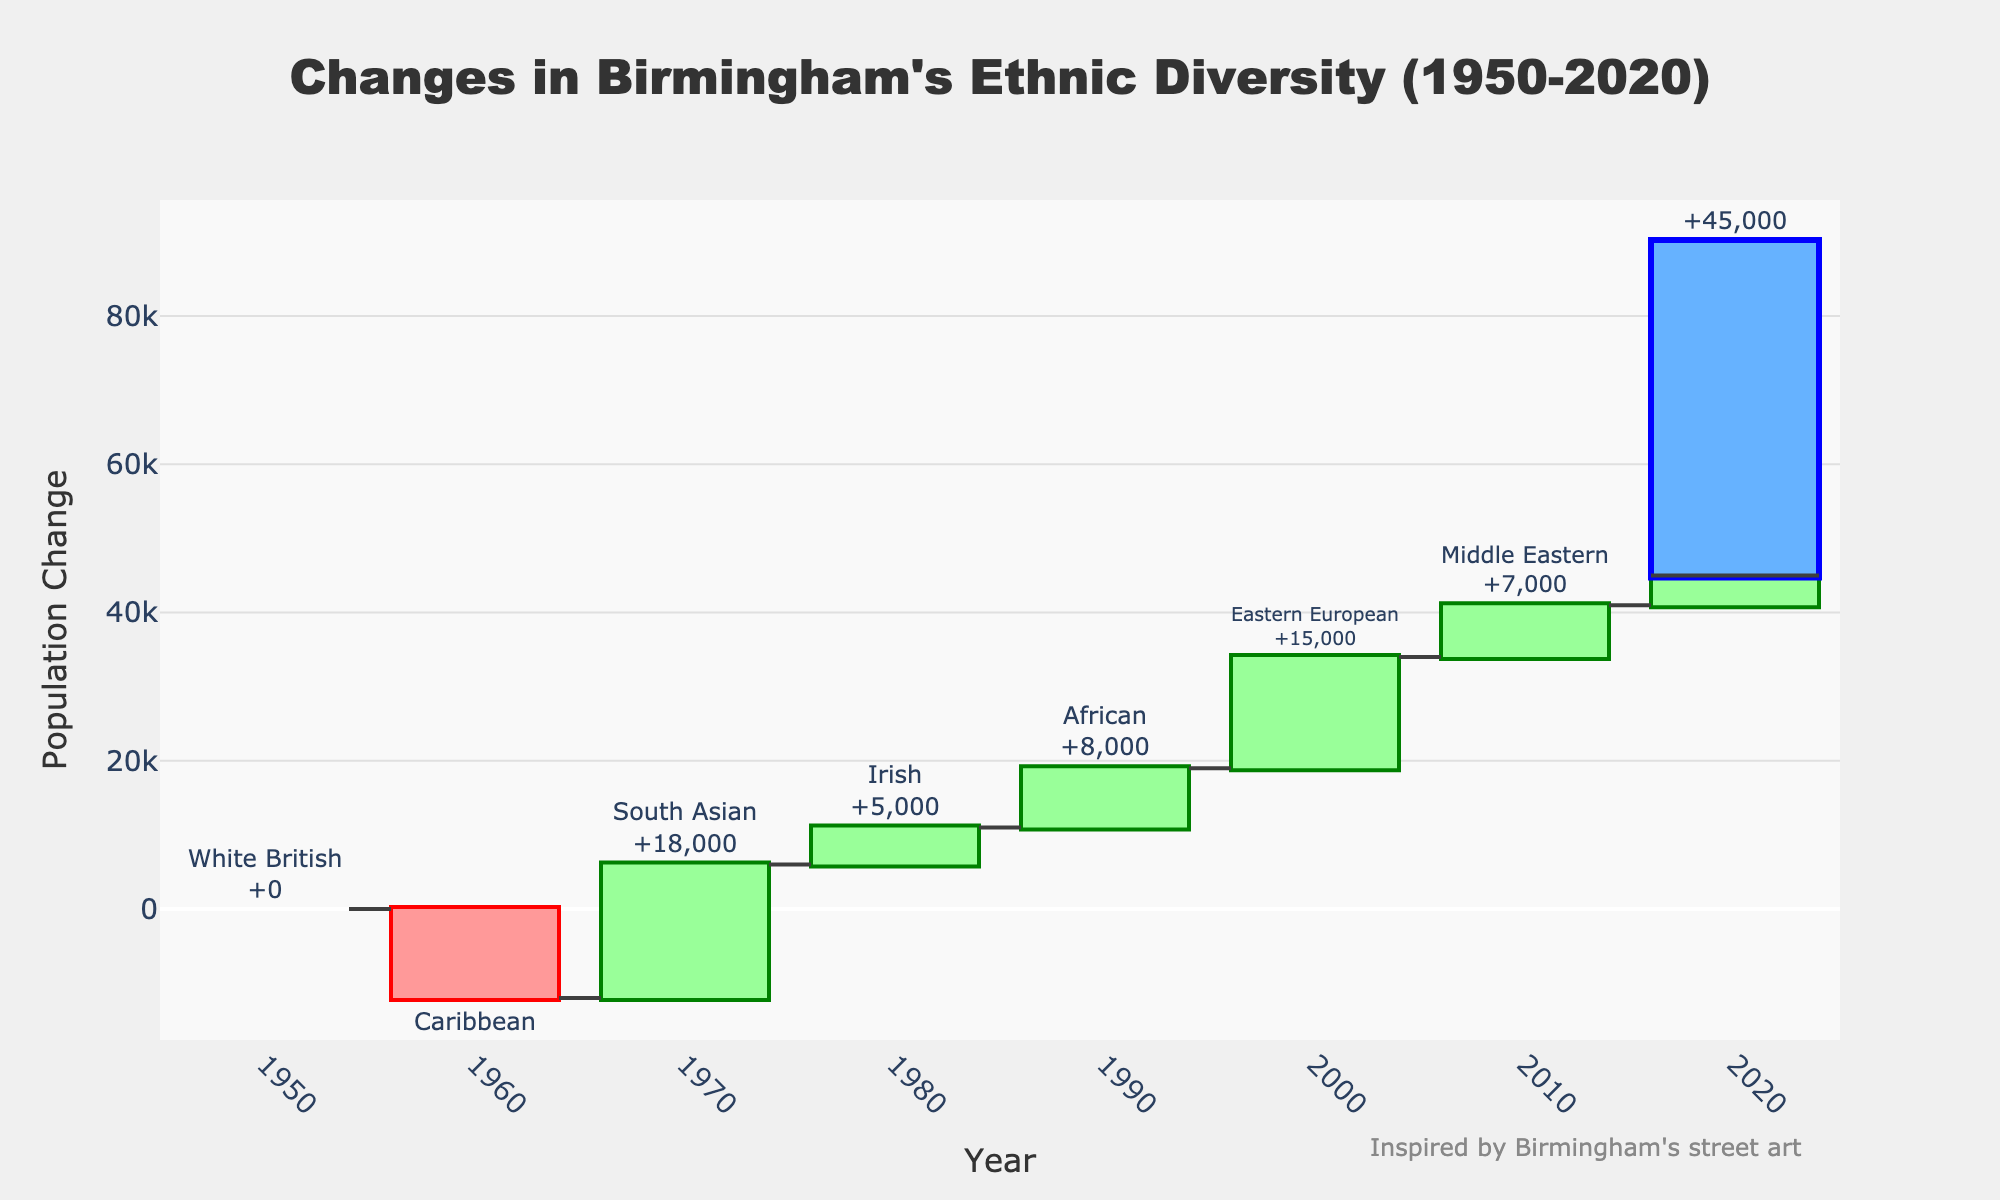What is the title of the chart? The title of the chart is at the top and reads "Changes in Birmingham's Ethnic Diversity (1950-2020).
Answer: Changes in Birmingham's Ethnic Diversity (1950-2020) How many ethnic groups are tracked in the chart? Each bar excluding the total bar represents a different ethnic group. Counting these bars gives us seven different ethnic groups.
Answer: Seven Which ethnic group saw the largest increase in population change? By visually inspecting the bars, the South Asian ethnic group (1970) has the largest increase, indicated by the tallest green bar.
Answer: South Asian What is the total change in ethnic diversity by 2020? The total change is represented by the final bar, which sums all previous changes and is labeled as 45,000.
Answer: 45,000 Which ethnic group experienced a decrease in population change and by how much? The only ethnic group with a red (decreasing) bar is the Caribbean (1960) with a change of -12,000.
Answer: Caribbean, -12,000 What was the combined population change for African and Eastern European ethnic groups? The change for African is 8,000 and for Eastern European is 15,000. Combined, this is 8,000 + 15,000 = 23,000.
Answer: 23,000 Which years saw the addition of more than 10,000 people to Birmingham's population? The years with bars taller than the 10,000 mark are 1970 (South Asian with 18,000) and 2000 (Eastern European with 15,000).
Answer: 1970 and 2000 In which year did the Irish ethnic group see a population change and what was the value? According to the chart, the Irish ethnic group appears in 1980 with a change of 5,000.
Answer: 1980, 5,000 What was the average population change for the Middle Eastern and Chinese ethnic groups? The Middle Eastern change is 7,000 and the Chinese change is 4,000. The average is (7,000 + 4,000) / 2 = 5,500.
Answer: 5,500 